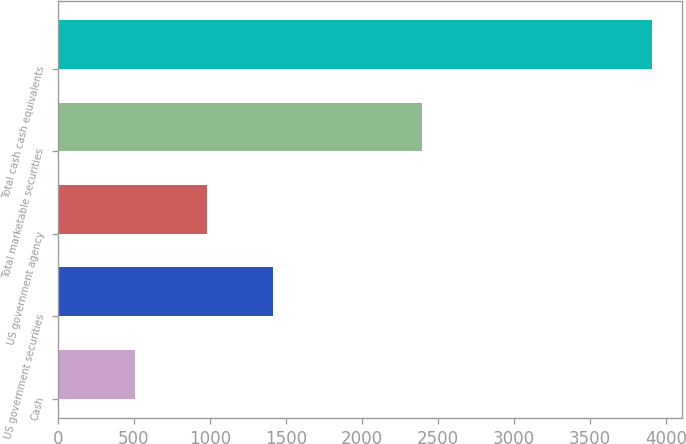<chart> <loc_0><loc_0><loc_500><loc_500><bar_chart><fcel>Cash<fcel>US government securities<fcel>US government agency<fcel>Total marketable securities<fcel>Total cash cash equivalents<nl><fcel>510<fcel>1415<fcel>981<fcel>2396<fcel>3908<nl></chart> 